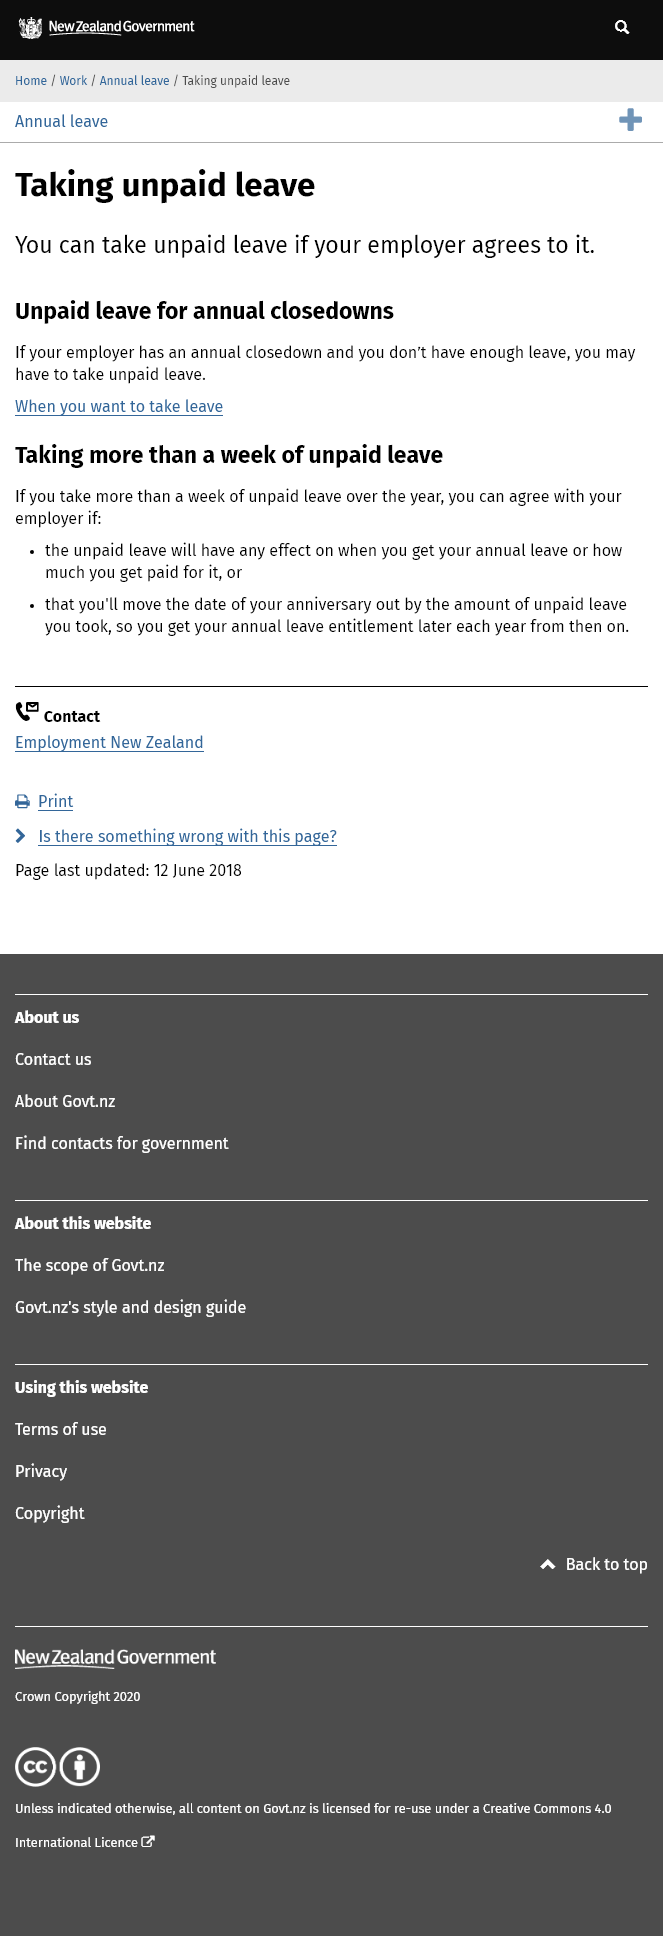Draw attention to some important aspects in this diagram. If an employee's employer has a yearly shutdown and the employee does not have enough leave, they may be required to take unpaid leave. It is permissible for an employee to take unpaid leave if their employer agrees to it. Taking unpaid leave may result in a reduction of your annual holiday entitlement, either in terms of the number of days or the value of each day, or may require a new anniversary date for your annual leave to renew, with the possibility of renewal occurring later each year. 